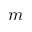Convert formula to latex. <formula><loc_0><loc_0><loc_500><loc_500>m</formula> 